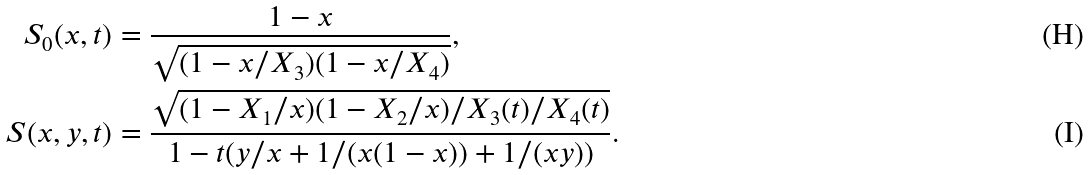Convert formula to latex. <formula><loc_0><loc_0><loc_500><loc_500>S _ { 0 } ( x , t ) & = \frac { 1 - x } { \sqrt { ( 1 - x / X _ { 3 } ) ( 1 - x / X _ { 4 } ) } } , \\ S ( x , y , t ) & = \frac { \sqrt { ( 1 - X _ { 1 } / x ) ( 1 - X _ { 2 } / x ) / X _ { 3 } ( t ) / X _ { 4 } ( t ) } } { 1 - t ( y / x + 1 / ( x ( 1 - x ) ) + 1 / ( x y ) ) } .</formula> 